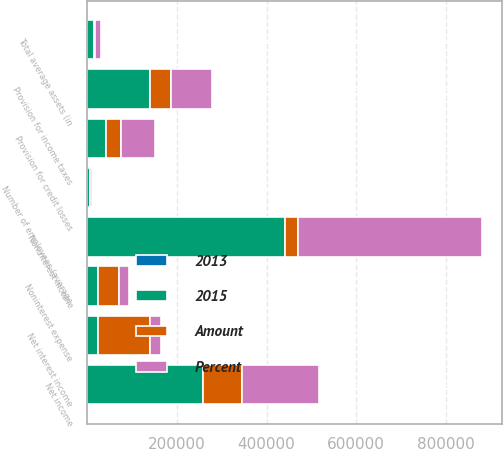<chart> <loc_0><loc_0><loc_500><loc_500><stacked_bar_chart><ecel><fcel>Net interest income<fcel>Provision for credit losses<fcel>Noninterest income<fcel>Noninterest expense<fcel>Provision for income taxes<fcel>Net income<fcel>Number of employees (average<fcel>Total average assets (in<nl><fcel>2015<fcel>23080<fcel>42828<fcel>440261<fcel>23080<fcel>139280<fcel>258664<fcel>5449<fcel>15645<nl><fcel>Percent<fcel>23080<fcel>75529<fcel>409746<fcel>23080<fcel>92722<fcel>172199<fcel>5239<fcel>14861<nl><fcel>Amount<fcel>117246<fcel>32701<fcel>30515<fcel>47439<fcel>46558<fcel>86465<fcel>210<fcel>784<nl><fcel>2013<fcel>13<fcel>43<fcel>7<fcel>5<fcel>50<fcel>50<fcel>4<fcel>5<nl></chart> 